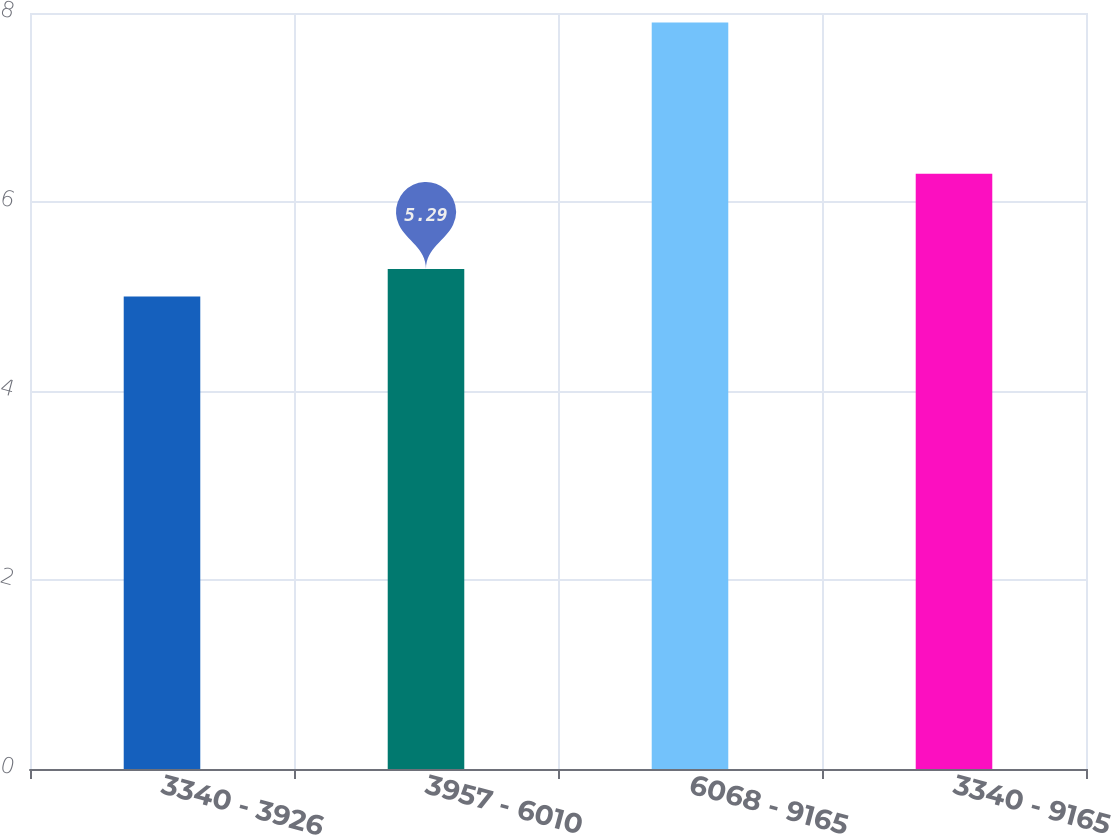<chart> <loc_0><loc_0><loc_500><loc_500><bar_chart><fcel>3340 - 3926<fcel>3957 - 6010<fcel>6068 - 9165<fcel>3340 - 9165<nl><fcel>5<fcel>5.29<fcel>7.9<fcel>6.3<nl></chart> 